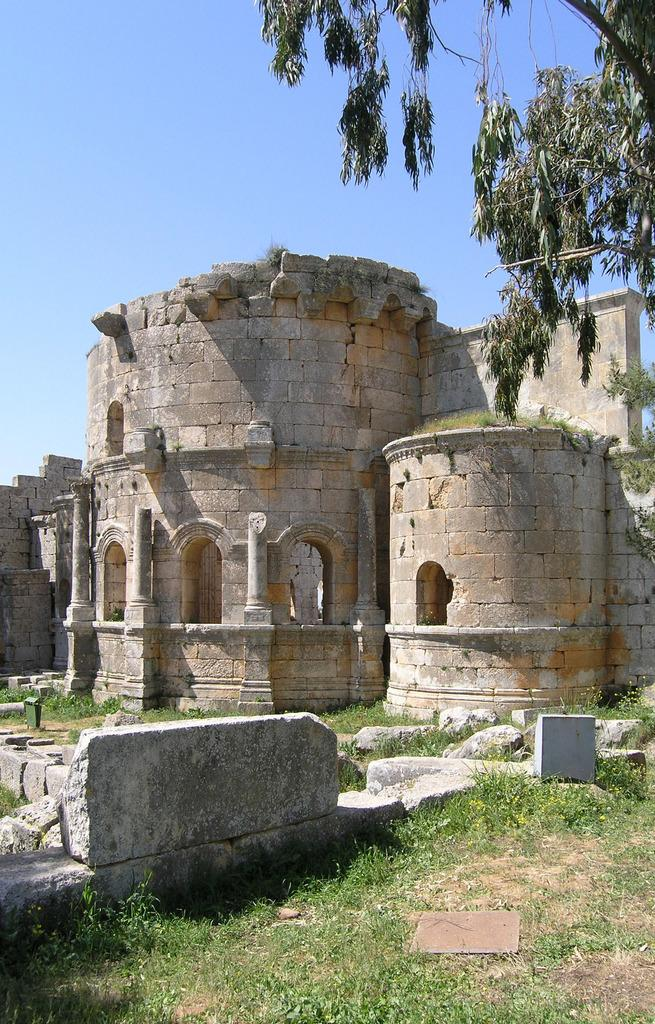What type of vegetation can be seen in the image? There is grass in the image. What type of structure is present in the image? There is a stone building in the image. What other natural element can be seen in the image? There is a tree in the image. How many grapes are hanging from the tree in the image? There are no grapes present in the image; it features a tree without any visible fruit. What type of carriage can be seen in the image? There is no carriage present in the image; it only contains grass, a stone building, and a tree. 